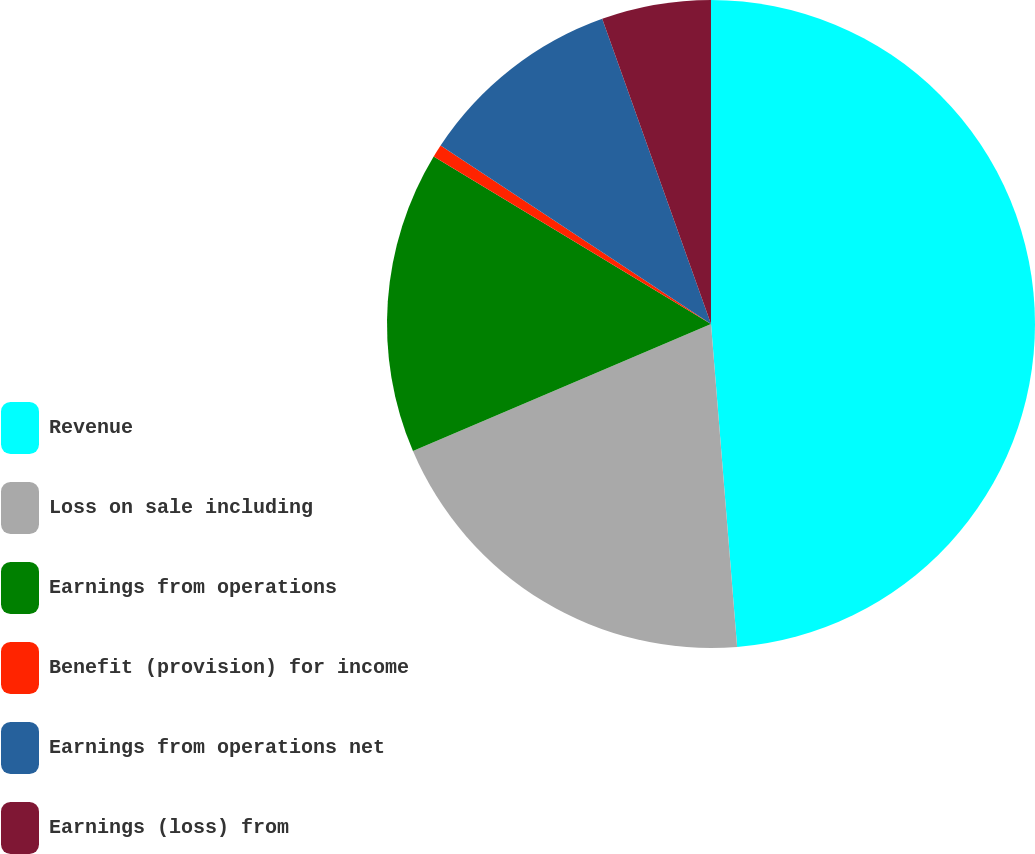Convert chart. <chart><loc_0><loc_0><loc_500><loc_500><pie_chart><fcel>Revenue<fcel>Loss on sale including<fcel>Earnings from operations<fcel>Benefit (provision) for income<fcel>Earnings from operations net<fcel>Earnings (loss) from<nl><fcel>48.71%<fcel>19.87%<fcel>15.06%<fcel>0.64%<fcel>10.26%<fcel>5.45%<nl></chart> 